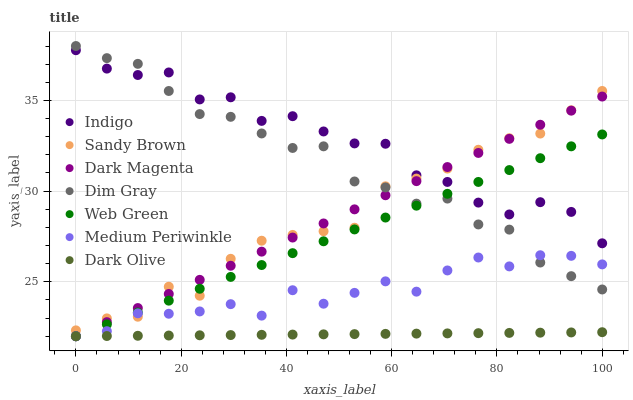Does Dark Olive have the minimum area under the curve?
Answer yes or no. Yes. Does Indigo have the maximum area under the curve?
Answer yes or no. Yes. Does Dark Magenta have the minimum area under the curve?
Answer yes or no. No. Does Dark Magenta have the maximum area under the curve?
Answer yes or no. No. Is Dark Olive the smoothest?
Answer yes or no. Yes. Is Indigo the roughest?
Answer yes or no. Yes. Is Dark Magenta the smoothest?
Answer yes or no. No. Is Dark Magenta the roughest?
Answer yes or no. No. Does Dark Magenta have the lowest value?
Answer yes or no. Yes. Does Indigo have the lowest value?
Answer yes or no. No. Does Dim Gray have the highest value?
Answer yes or no. Yes. Does Indigo have the highest value?
Answer yes or no. No. Is Medium Periwinkle less than Indigo?
Answer yes or no. Yes. Is Indigo greater than Medium Periwinkle?
Answer yes or no. Yes. Does Dim Gray intersect Medium Periwinkle?
Answer yes or no. Yes. Is Dim Gray less than Medium Periwinkle?
Answer yes or no. No. Is Dim Gray greater than Medium Periwinkle?
Answer yes or no. No. Does Medium Periwinkle intersect Indigo?
Answer yes or no. No. 